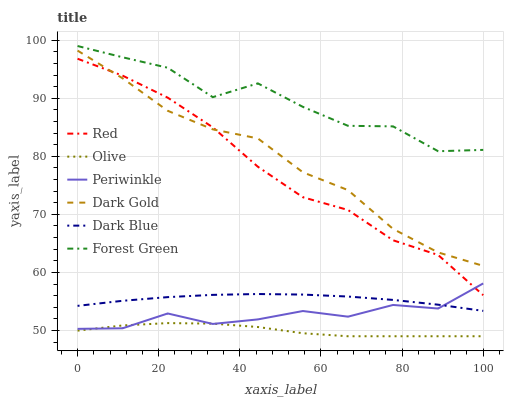Does Olive have the minimum area under the curve?
Answer yes or no. Yes. Does Forest Green have the maximum area under the curve?
Answer yes or no. Yes. Does Dark Blue have the minimum area under the curve?
Answer yes or no. No. Does Dark Blue have the maximum area under the curve?
Answer yes or no. No. Is Dark Blue the smoothest?
Answer yes or no. Yes. Is Forest Green the roughest?
Answer yes or no. Yes. Is Forest Green the smoothest?
Answer yes or no. No. Is Dark Blue the roughest?
Answer yes or no. No. Does Olive have the lowest value?
Answer yes or no. Yes. Does Dark Blue have the lowest value?
Answer yes or no. No. Does Forest Green have the highest value?
Answer yes or no. Yes. Does Dark Blue have the highest value?
Answer yes or no. No. Is Dark Gold less than Forest Green?
Answer yes or no. Yes. Is Dark Gold greater than Dark Blue?
Answer yes or no. Yes. Does Periwinkle intersect Red?
Answer yes or no. Yes. Is Periwinkle less than Red?
Answer yes or no. No. Is Periwinkle greater than Red?
Answer yes or no. No. Does Dark Gold intersect Forest Green?
Answer yes or no. No. 